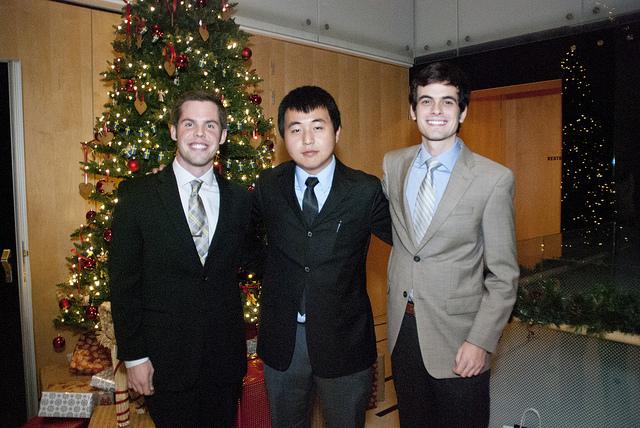Are they all friends?
Keep it brief. Yes. What season is this?
Quick response, please. Christmas. Is this a business meeting?
Keep it brief. No. Is this a recent picture?
Quick response, please. Yes. How many men are wearing Khaki pants?
Answer briefly. 0. How many boys?
Give a very brief answer. 3. Are all the men wearing ties?
Write a very short answer. Yes. What type of plant is next to the man?
Give a very brief answer. Christmas tree. What ethnicity are the majority of the people in this scene?
Give a very brief answer. White. How many women are in the picture?
Concise answer only. 0. How many of these people are male?
Quick response, please. 3. How many people are in the photo?
Concise answer only. 3. How many Christmas trees are in the background?
Quick response, please. 2. Is it day or night?
Answer briefly. Night. What color is the wall behind the men?
Concise answer only. Brown. What is hanging on the walls?
Give a very brief answer. Lights. How many men are in this photo?
Answer briefly. 3. What are the men looking at?
Answer briefly. Camera. How many men are in this picture?
Answer briefly. 3. Are they at a wedding?
Concise answer only. No. 